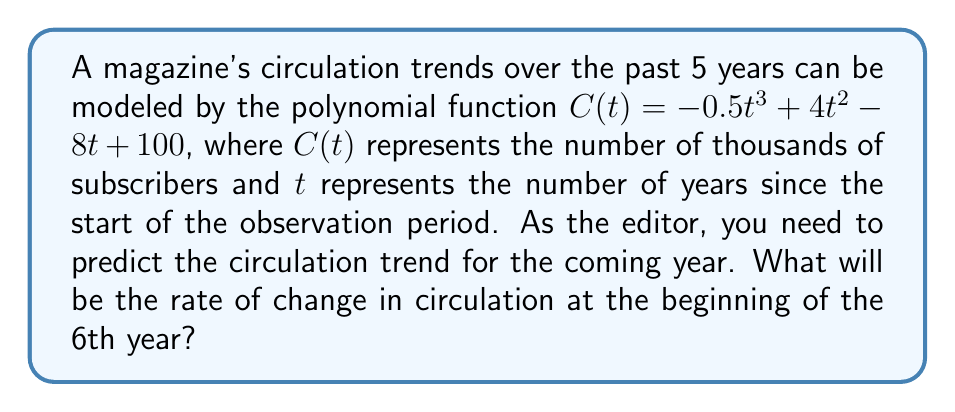Provide a solution to this math problem. To find the rate of change in circulation at the beginning of the 6th year, we need to follow these steps:

1. The rate of change is represented by the first derivative of the function $C(t)$.

2. Let's find the first derivative of $C(t)$:
   $$C'(t) = \frac{d}{dt}(-0.5t^3 + 4t^2 - 8t + 100)$$
   $$C'(t) = -1.5t^2 + 8t - 8$$

3. We want to know the rate of change at the beginning of the 6th year, so we need to evaluate $C'(t)$ at $t = 5$:
   $$C'(5) = -1.5(5)^2 + 8(5) - 8$$
   $$C'(5) = -1.5(25) + 40 - 8$$
   $$C'(5) = -37.5 + 40 - 8$$
   $$C'(5) = -5.5$$

4. The negative value indicates a decreasing trend.

5. Remember that $C(t)$ is in thousands of subscribers, so we need to multiply our result by 1000 to get the actual number of subscribers.

Therefore, at the beginning of the 6th year, the circulation is decreasing at a rate of 5,500 subscribers per year.
Answer: -5,500 subscribers per year 